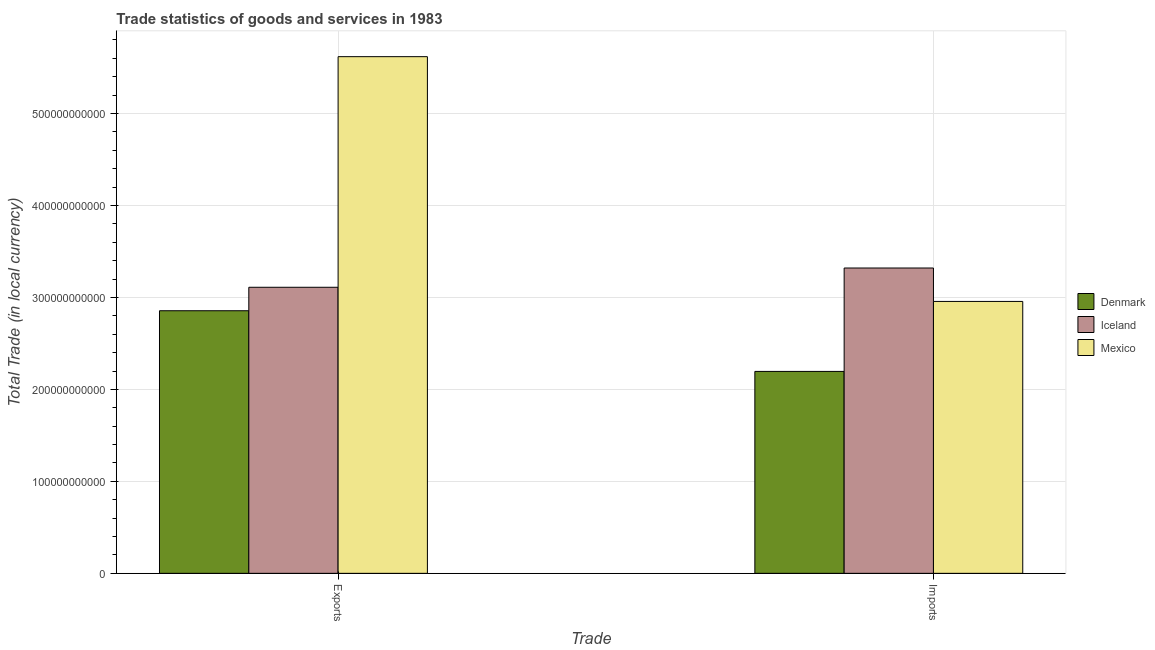Are the number of bars per tick equal to the number of legend labels?
Your answer should be compact. Yes. How many bars are there on the 2nd tick from the left?
Provide a succinct answer. 3. What is the label of the 1st group of bars from the left?
Provide a succinct answer. Exports. What is the export of goods and services in Denmark?
Offer a very short reply. 2.86e+11. Across all countries, what is the maximum imports of goods and services?
Make the answer very short. 3.32e+11. Across all countries, what is the minimum imports of goods and services?
Your answer should be very brief. 2.20e+11. In which country was the imports of goods and services maximum?
Provide a succinct answer. Iceland. What is the total imports of goods and services in the graph?
Provide a succinct answer. 8.47e+11. What is the difference between the imports of goods and services in Iceland and that in Mexico?
Your answer should be compact. 3.63e+1. What is the difference between the export of goods and services in Denmark and the imports of goods and services in Iceland?
Provide a short and direct response. -4.65e+1. What is the average imports of goods and services per country?
Ensure brevity in your answer.  2.82e+11. What is the difference between the imports of goods and services and export of goods and services in Mexico?
Make the answer very short. -2.66e+11. What is the ratio of the export of goods and services in Denmark to that in Iceland?
Your answer should be very brief. 0.92. In how many countries, is the export of goods and services greater than the average export of goods and services taken over all countries?
Provide a short and direct response. 1. What does the 2nd bar from the left in Exports represents?
Provide a succinct answer. Iceland. What does the 1st bar from the right in Exports represents?
Give a very brief answer. Mexico. Are all the bars in the graph horizontal?
Provide a short and direct response. No. What is the difference between two consecutive major ticks on the Y-axis?
Make the answer very short. 1.00e+11. Are the values on the major ticks of Y-axis written in scientific E-notation?
Make the answer very short. No. Does the graph contain any zero values?
Offer a very short reply. No. Where does the legend appear in the graph?
Ensure brevity in your answer.  Center right. How many legend labels are there?
Your answer should be very brief. 3. What is the title of the graph?
Provide a succinct answer. Trade statistics of goods and services in 1983. Does "High income: OECD" appear as one of the legend labels in the graph?
Keep it short and to the point. No. What is the label or title of the X-axis?
Offer a very short reply. Trade. What is the label or title of the Y-axis?
Your answer should be very brief. Total Trade (in local currency). What is the Total Trade (in local currency) of Denmark in Exports?
Ensure brevity in your answer.  2.86e+11. What is the Total Trade (in local currency) in Iceland in Exports?
Your answer should be very brief. 3.11e+11. What is the Total Trade (in local currency) in Mexico in Exports?
Your response must be concise. 5.62e+11. What is the Total Trade (in local currency) in Denmark in Imports?
Make the answer very short. 2.20e+11. What is the Total Trade (in local currency) of Iceland in Imports?
Offer a very short reply. 3.32e+11. What is the Total Trade (in local currency) in Mexico in Imports?
Your response must be concise. 2.96e+11. Across all Trade, what is the maximum Total Trade (in local currency) of Denmark?
Ensure brevity in your answer.  2.86e+11. Across all Trade, what is the maximum Total Trade (in local currency) of Iceland?
Ensure brevity in your answer.  3.32e+11. Across all Trade, what is the maximum Total Trade (in local currency) of Mexico?
Make the answer very short. 5.62e+11. Across all Trade, what is the minimum Total Trade (in local currency) in Denmark?
Give a very brief answer. 2.20e+11. Across all Trade, what is the minimum Total Trade (in local currency) of Iceland?
Provide a succinct answer. 3.11e+11. Across all Trade, what is the minimum Total Trade (in local currency) in Mexico?
Offer a very short reply. 2.96e+11. What is the total Total Trade (in local currency) of Denmark in the graph?
Your response must be concise. 5.05e+11. What is the total Total Trade (in local currency) of Iceland in the graph?
Your answer should be compact. 6.43e+11. What is the total Total Trade (in local currency) of Mexico in the graph?
Your answer should be very brief. 8.58e+11. What is the difference between the Total Trade (in local currency) in Denmark in Exports and that in Imports?
Your answer should be very brief. 6.60e+1. What is the difference between the Total Trade (in local currency) of Iceland in Exports and that in Imports?
Your answer should be very brief. -2.10e+1. What is the difference between the Total Trade (in local currency) of Mexico in Exports and that in Imports?
Your answer should be very brief. 2.66e+11. What is the difference between the Total Trade (in local currency) in Denmark in Exports and the Total Trade (in local currency) in Iceland in Imports?
Ensure brevity in your answer.  -4.65e+1. What is the difference between the Total Trade (in local currency) of Denmark in Exports and the Total Trade (in local currency) of Mexico in Imports?
Your answer should be compact. -1.01e+1. What is the difference between the Total Trade (in local currency) of Iceland in Exports and the Total Trade (in local currency) of Mexico in Imports?
Make the answer very short. 1.54e+1. What is the average Total Trade (in local currency) in Denmark per Trade?
Offer a very short reply. 2.53e+11. What is the average Total Trade (in local currency) of Iceland per Trade?
Give a very brief answer. 3.22e+11. What is the average Total Trade (in local currency) in Mexico per Trade?
Offer a terse response. 4.29e+11. What is the difference between the Total Trade (in local currency) of Denmark and Total Trade (in local currency) of Iceland in Exports?
Your response must be concise. -2.55e+1. What is the difference between the Total Trade (in local currency) of Denmark and Total Trade (in local currency) of Mexico in Exports?
Your answer should be compact. -2.76e+11. What is the difference between the Total Trade (in local currency) in Iceland and Total Trade (in local currency) in Mexico in Exports?
Keep it short and to the point. -2.51e+11. What is the difference between the Total Trade (in local currency) in Denmark and Total Trade (in local currency) in Iceland in Imports?
Ensure brevity in your answer.  -1.12e+11. What is the difference between the Total Trade (in local currency) in Denmark and Total Trade (in local currency) in Mexico in Imports?
Your answer should be compact. -7.61e+1. What is the difference between the Total Trade (in local currency) in Iceland and Total Trade (in local currency) in Mexico in Imports?
Your response must be concise. 3.63e+1. What is the ratio of the Total Trade (in local currency) of Denmark in Exports to that in Imports?
Provide a short and direct response. 1.3. What is the ratio of the Total Trade (in local currency) of Iceland in Exports to that in Imports?
Keep it short and to the point. 0.94. What is the ratio of the Total Trade (in local currency) in Mexico in Exports to that in Imports?
Offer a very short reply. 1.9. What is the difference between the highest and the second highest Total Trade (in local currency) of Denmark?
Your response must be concise. 6.60e+1. What is the difference between the highest and the second highest Total Trade (in local currency) of Iceland?
Make the answer very short. 2.10e+1. What is the difference between the highest and the second highest Total Trade (in local currency) in Mexico?
Your answer should be compact. 2.66e+11. What is the difference between the highest and the lowest Total Trade (in local currency) in Denmark?
Your answer should be compact. 6.60e+1. What is the difference between the highest and the lowest Total Trade (in local currency) in Iceland?
Provide a short and direct response. 2.10e+1. What is the difference between the highest and the lowest Total Trade (in local currency) of Mexico?
Give a very brief answer. 2.66e+11. 